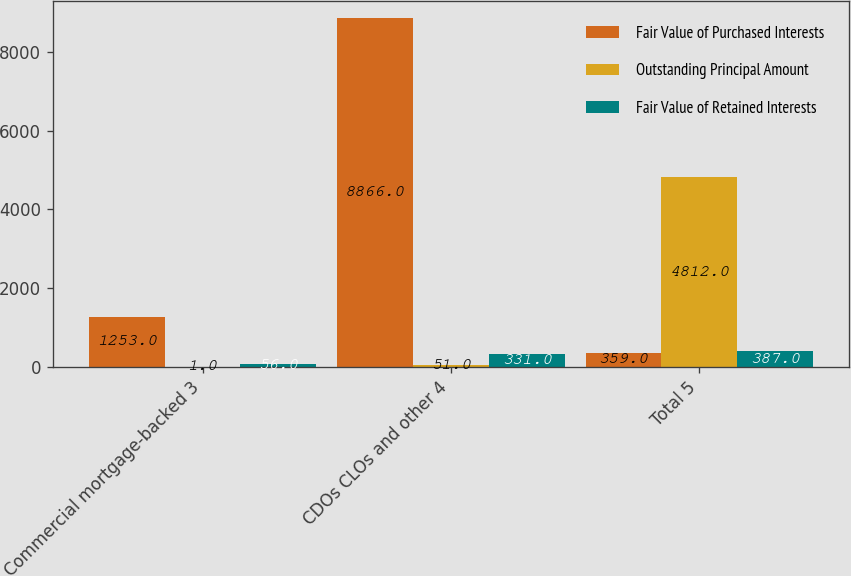Convert chart. <chart><loc_0><loc_0><loc_500><loc_500><stacked_bar_chart><ecel><fcel>Commercial mortgage-backed 3<fcel>CDOs CLOs and other 4<fcel>Total 5<nl><fcel>Fair Value of Purchased Interests<fcel>1253<fcel>8866<fcel>359<nl><fcel>Outstanding Principal Amount<fcel>1<fcel>51<fcel>4812<nl><fcel>Fair Value of Retained Interests<fcel>56<fcel>331<fcel>387<nl></chart> 